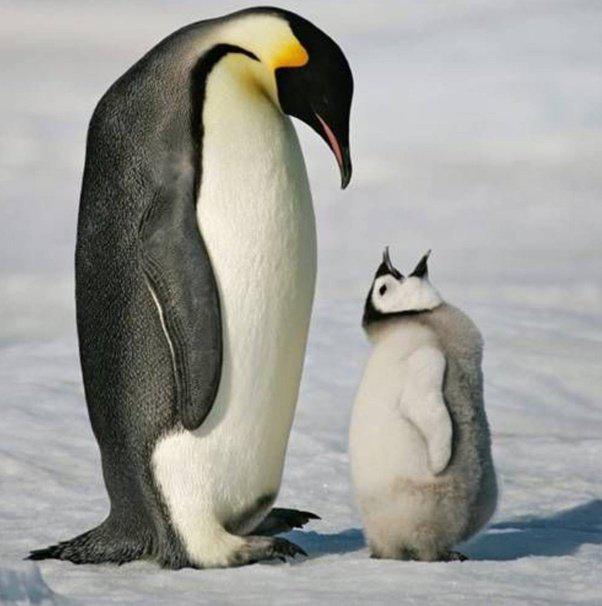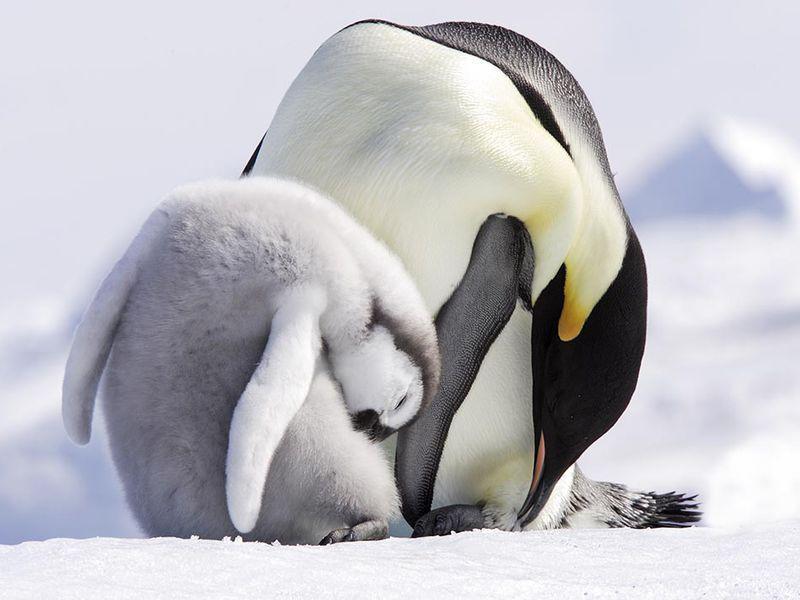The first image is the image on the left, the second image is the image on the right. Examine the images to the left and right. Is the description "A baby penguin is standing near its mother with its mouth open." accurate? Answer yes or no. Yes. 